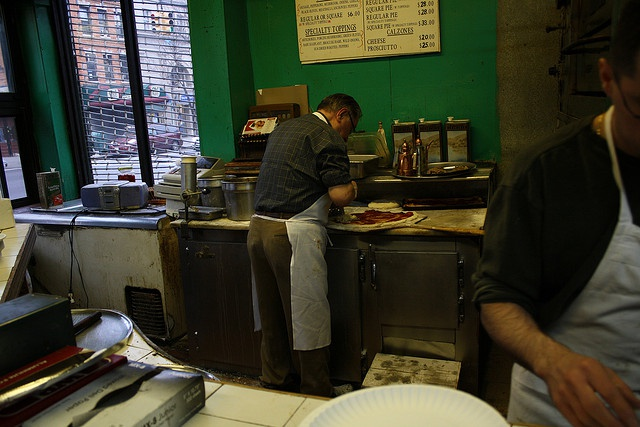Describe the objects in this image and their specific colors. I can see people in black, maroon, gray, and olive tones, people in black, gray, and darkgreen tones, oven in black, olive, and tan tones, oven in black, darkgreen, and gray tones, and car in black, purple, darkgray, and gray tones in this image. 